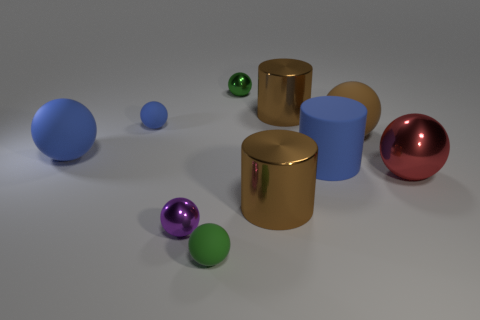Is the color of the small metal object behind the blue rubber cylinder the same as the rubber ball in front of the red metallic thing?
Ensure brevity in your answer.  Yes. What is the color of the other metallic sphere that is the same size as the purple shiny ball?
Ensure brevity in your answer.  Green. What number of objects are objects that are to the left of the tiny green shiny ball or tiny green shiny things?
Keep it short and to the point. 5. What number of other things are there of the same size as the blue matte cylinder?
Provide a short and direct response. 5. How big is the metallic cylinder in front of the tiny blue thing?
Provide a succinct answer. Large. There is a tiny purple thing that is the same material as the large red ball; what shape is it?
Keep it short and to the point. Sphere. Are there any other things of the same color as the big matte cylinder?
Make the answer very short. Yes. What color is the small ball that is right of the rubber thing in front of the large blue cylinder?
Provide a short and direct response. Green. What number of big things are green shiny balls or spheres?
Keep it short and to the point. 3. There is a brown thing that is the same shape as the small blue rubber object; what is its material?
Provide a succinct answer. Rubber. 